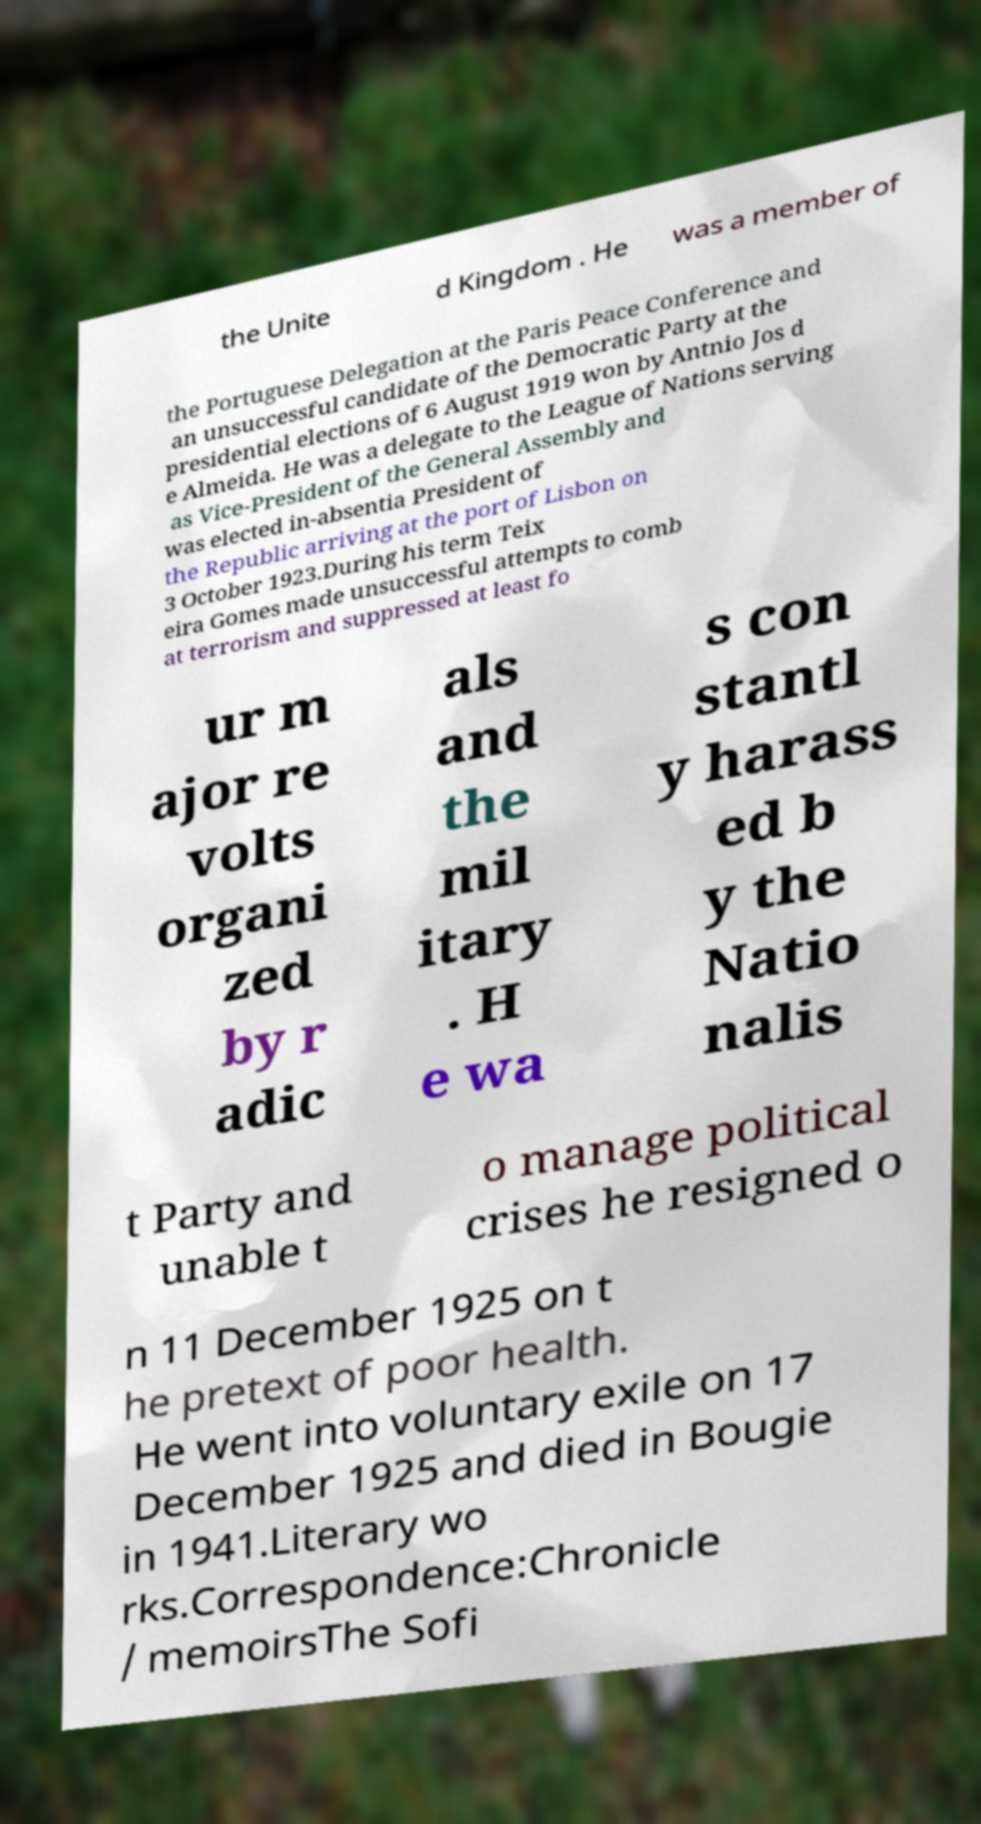Can you accurately transcribe the text from the provided image for me? the Unite d Kingdom . He was a member of the Portuguese Delegation at the Paris Peace Conference and an unsuccessful candidate of the Democratic Party at the presidential elections of 6 August 1919 won by Antnio Jos d e Almeida. He was a delegate to the League of Nations serving as Vice-President of the General Assembly and was elected in-absentia President of the Republic arriving at the port of Lisbon on 3 October 1923.During his term Teix eira Gomes made unsuccessful attempts to comb at terrorism and suppressed at least fo ur m ajor re volts organi zed by r adic als and the mil itary . H e wa s con stantl y harass ed b y the Natio nalis t Party and unable t o manage political crises he resigned o n 11 December 1925 on t he pretext of poor health. He went into voluntary exile on 17 December 1925 and died in Bougie in 1941.Literary wo rks.Correspondence:Chronicle / memoirsThe Sofi 